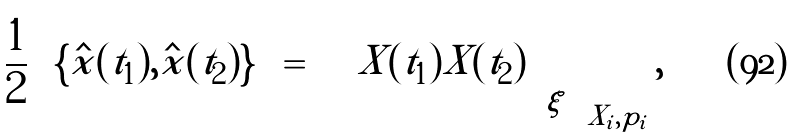Convert formula to latex. <formula><loc_0><loc_0><loc_500><loc_500>\frac { 1 } { 2 } \left \langle \left \{ \hat { x } ( t _ { 1 } ) , \hat { x } ( t _ { 2 } ) \right \} \right \rangle = \left \langle \left \langle X ( t _ { 1 } ) X ( t _ { 2 } ) \right \rangle _ { \xi } \right \rangle _ { X _ { i } , p _ { i } } ,</formula> 